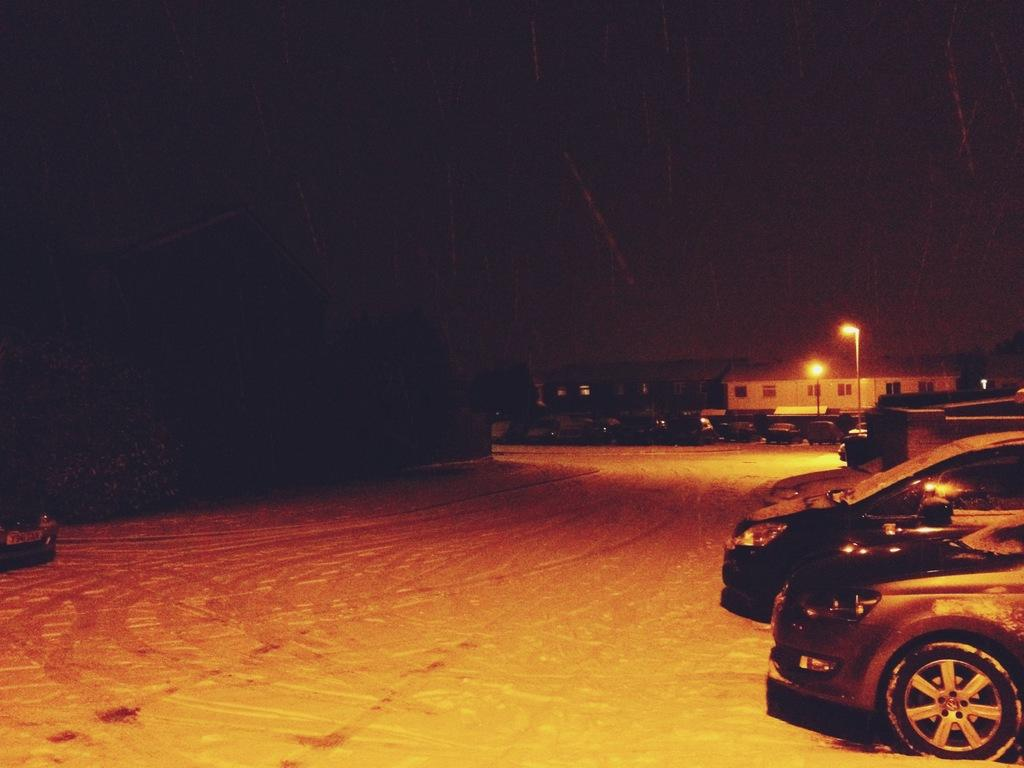What is the main feature of the image? There is a road in the image. What can be seen on the right side of the road? There are vehicles on the right side of the road. What is present in the background of the image? There are two street lights and a house in the background. What type of doll is sitting on the front porch of the house in the image? There is no doll present in the image; it only features a road, vehicles, street lights, and a house. 